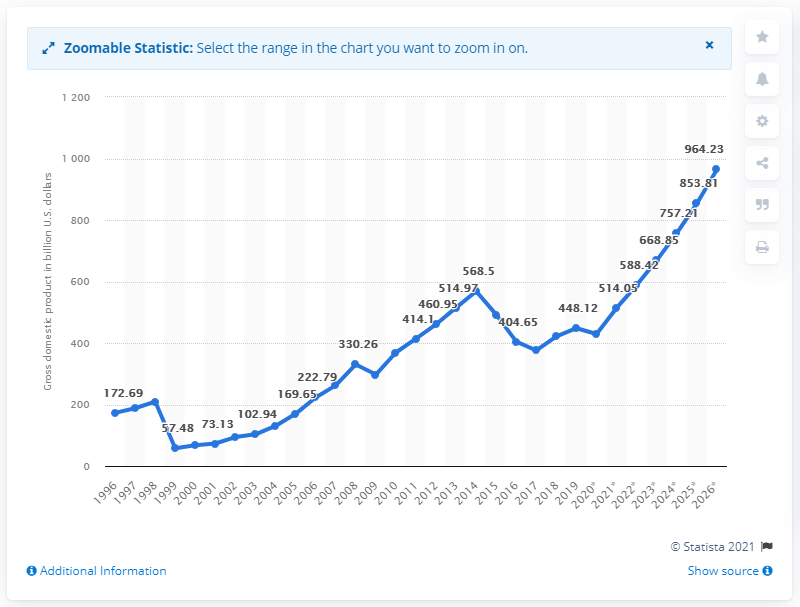Give some essential details in this illustration. In 2019, the gross domestic product of Nigeria was 448.12. 